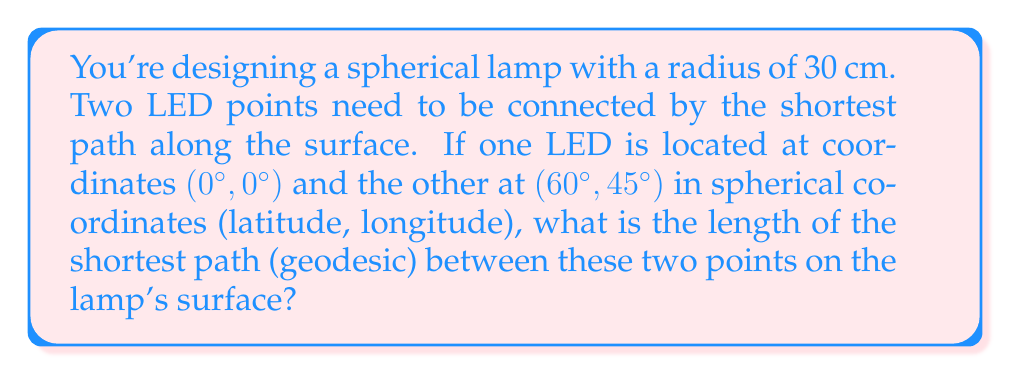Can you solve this math problem? To solve this problem, we'll use the formula for the great circle distance on a sphere, which represents the geodesic between two points. The steps are as follows:

1) First, we need to convert the coordinates from degrees to radians:
   Point 1: $(0°, 0°) = (0, 0)$ radians
   Point 2: $(60°, 45°) = (\frac{\pi}{3}, \frac{\pi}{4})$ radians

2) Let's denote the latitude and longitude of the first point as $(\phi_1, \lambda_1)$ and the second point as $(\phi_2, \lambda_2)$.

3) The formula for the central angle $\Delta\sigma$ between two points on a sphere is:

   $$\Delta\sigma = \arccos(\sin\phi_1 \sin\phi_2 + \cos\phi_1 \cos\phi_2 \cos(\Delta\lambda))$$

   where $\Delta\lambda = |\lambda_2 - \lambda_1|$

4) Substituting our values:

   $$\Delta\sigma = \arccos(\sin(0) \sin(\frac{\pi}{3}) + \cos(0) \cos(\frac{\pi}{3}) \cos(\frac{\pi}{4}))$$

5) Simplifying:

   $$\Delta\sigma = \arccos(0 + \cos(\frac{\pi}{3}) \cos(\frac{\pi}{4}))$$
   $$\Delta\sigma = \arccos(\frac{1}{2} \cdot \frac{\sqrt{2}}{2})$$
   $$\Delta\sigma = \arccos(\frac{\sqrt{2}}{4})$$

6) The length of the geodesic $L$ is then given by:

   $$L = R \cdot \Delta\sigma$$

   where $R$ is the radius of the sphere (30 cm in this case).

7) Therefore:

   $$L = 30 \cdot \arccos(\frac{\sqrt{2}}{4})$$

8) Using a calculator or computer, we can evaluate this to approximately 31.79 cm.
Answer: $30 \cdot \arccos(\frac{\sqrt{2}}{4})$ cm $\approx 31.79$ cm 